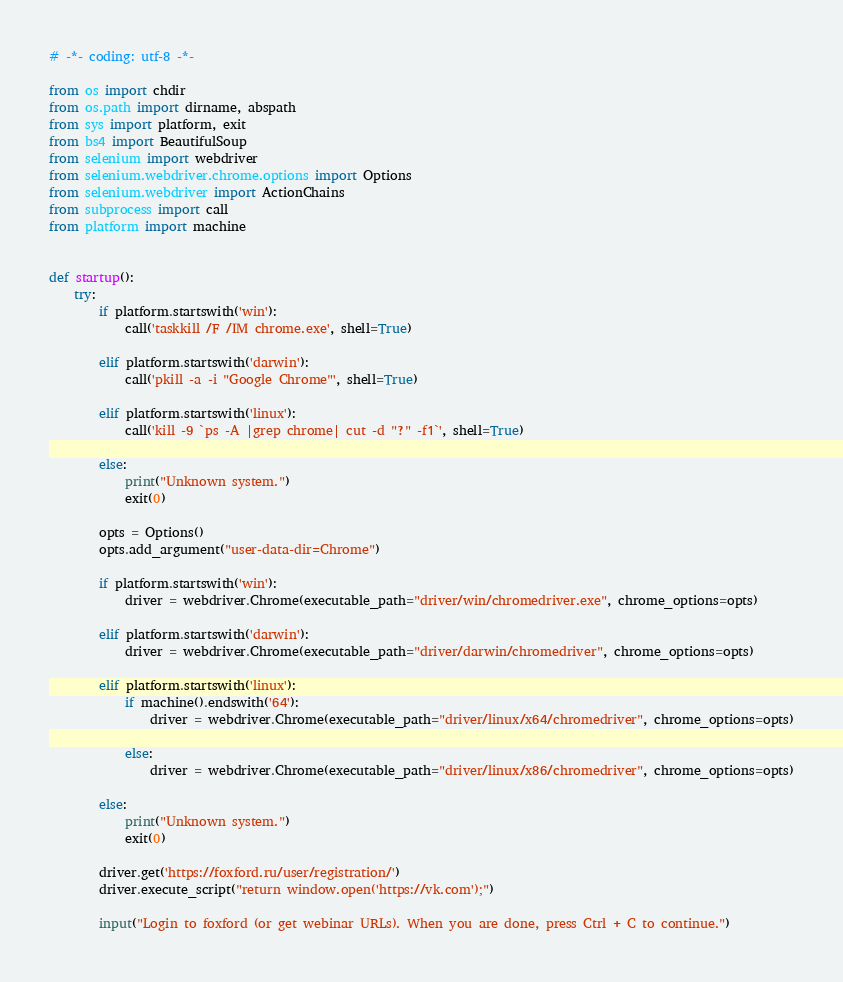<code> <loc_0><loc_0><loc_500><loc_500><_Python_># -*- coding: utf-8 -*-

from os import chdir
from os.path import dirname, abspath
from sys import platform, exit
from bs4 import BeautifulSoup
from selenium import webdriver
from selenium.webdriver.chrome.options import Options
from selenium.webdriver import ActionChains
from subprocess import call
from platform import machine


def startup():
	try:
		if platform.startswith('win'):
			call('taskkill /F /IM chrome.exe', shell=True)

		elif platform.startswith('darwin'):
			call('pkill -a -i "Google Chrome"', shell=True)

		elif platform.startswith('linux'):
			call('kill -9 `ps -A |grep chrome| cut -d "?" -f1`', shell=True)

		else:
			print("Unknown system.")
			exit(0)

		opts = Options()
		opts.add_argument("user-data-dir=Chrome")

		if platform.startswith('win'):
			driver = webdriver.Chrome(executable_path="driver/win/chromedriver.exe", chrome_options=opts)

		elif platform.startswith('darwin'):
			driver = webdriver.Chrome(executable_path="driver/darwin/chromedriver", chrome_options=opts)

		elif platform.startswith('linux'):
			if machine().endswith('64'):
				driver = webdriver.Chrome(executable_path="driver/linux/x64/chromedriver", chrome_options=opts)

			else:
				driver = webdriver.Chrome(executable_path="driver/linux/x86/chromedriver", chrome_options=opts)

		else:
			print("Unknown system.")
			exit(0)

		driver.get('https://foxford.ru/user/registration/')
		driver.execute_script("return window.open('https://vk.com');")

		input("Login to foxford (or get webinar URLs). When you are done, press Ctrl + C to continue.")
</code> 